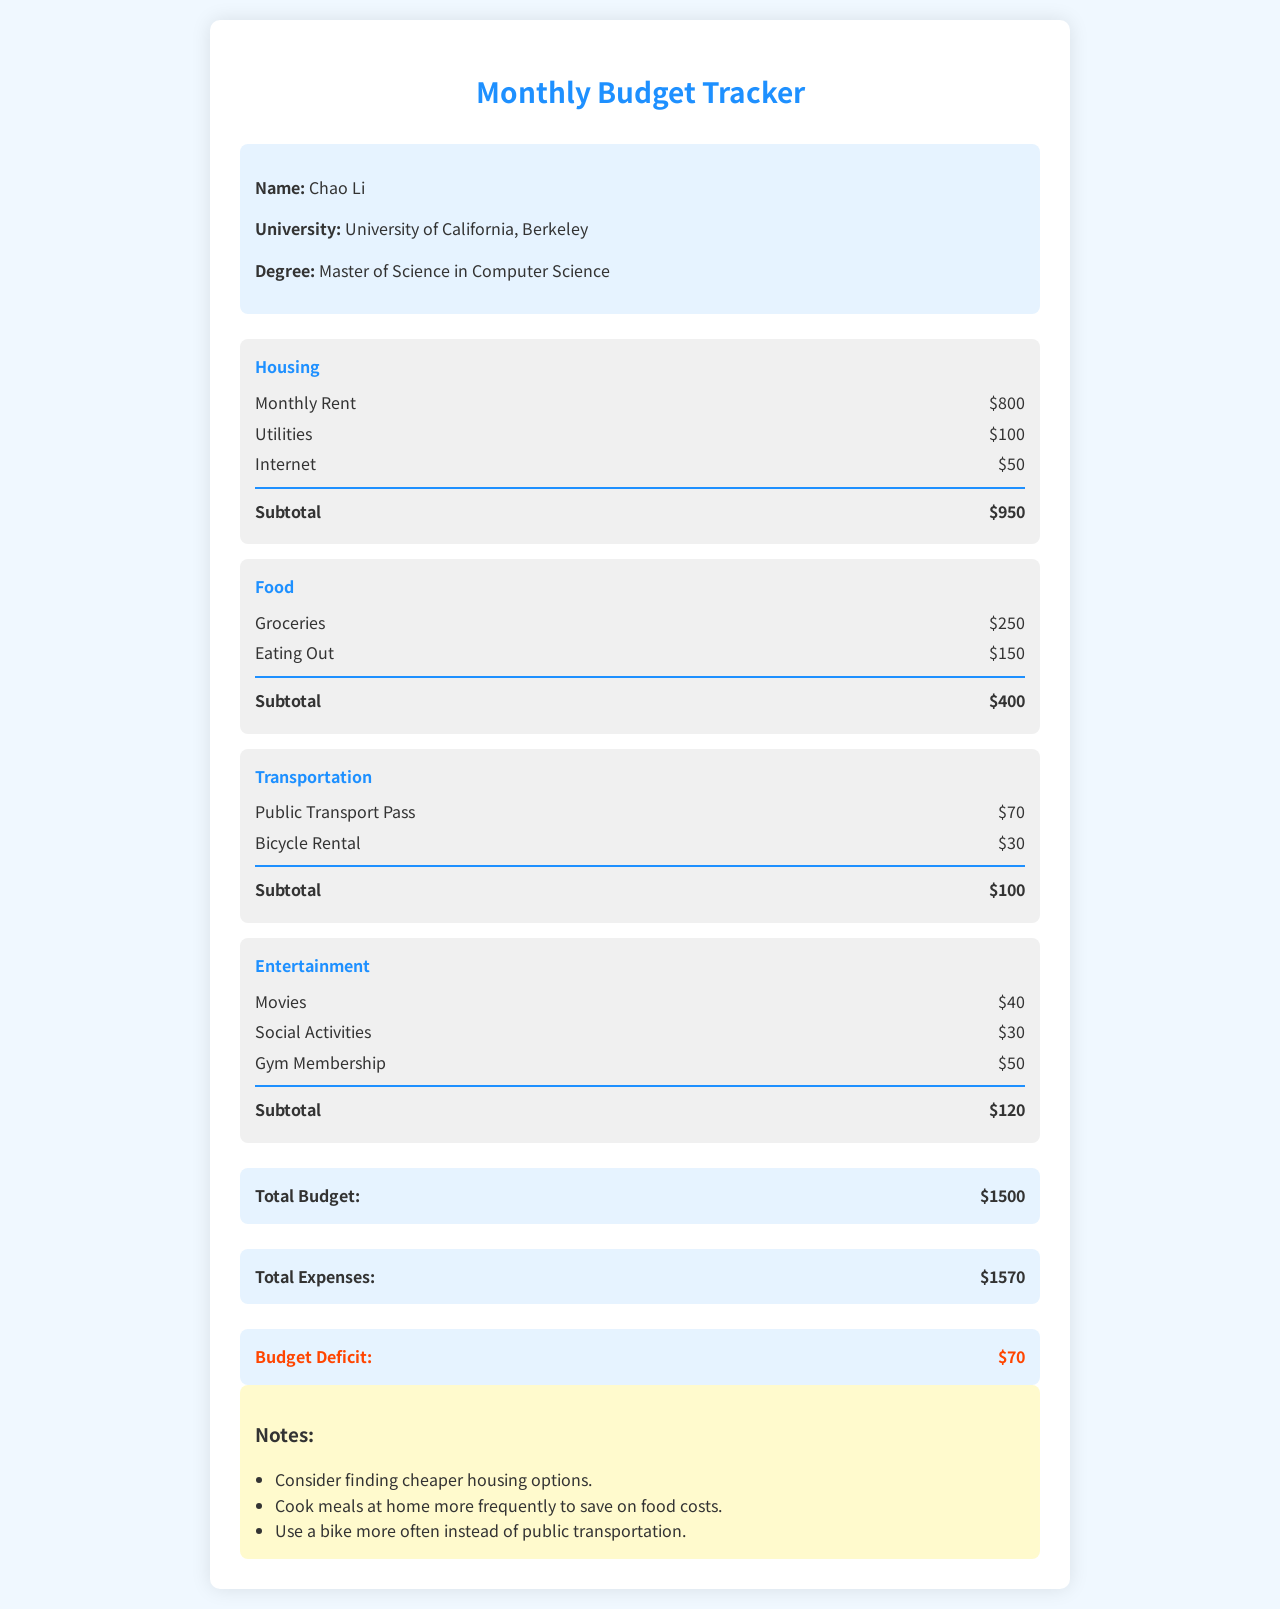What is the name of the student? The name of the student is mentioned in the document as "Chao Li."
Answer: Chao Li What is the total budget? The total budget can be found in the budget summary section as $1500.
Answer: $1500 How much is spent on groceries? The amount spent on groceries is listed under the food category as $250.
Answer: $250 What are the total expenses? The total expenses are provided in the budget summary section as $1570.
Answer: $1570 What is the amount for the budget deficit? The budget deficit is indicated in the document as $70.
Answer: $70 What is the subtotal for housing expenses? The subtotal for housing expenses is shown as $950.
Answer: $950 Which category has the highest expense? By comparing the subcategory totals, the highest expense is in the housing category.
Answer: Housing What is one suggestion mentioned in the notes? One suggestion in the notes is to "Consider finding cheaper housing options."
Answer: Consider finding cheaper housing options How much is spent on entertainment? The amount spent on entertainment, as shown in the document, is $120.
Answer: $120 